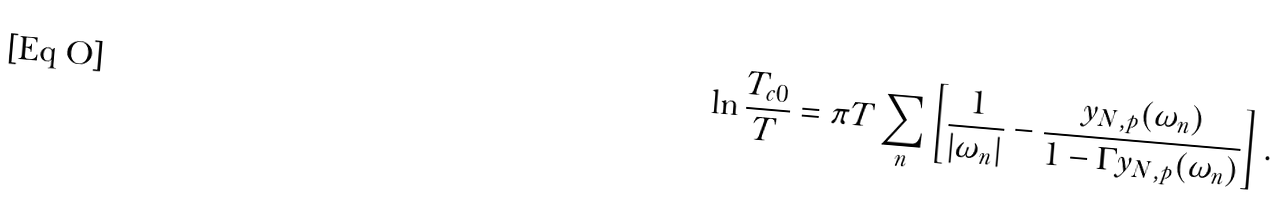<formula> <loc_0><loc_0><loc_500><loc_500>\ln \frac { T _ { c 0 } } { T } = \pi T \sum _ { n } \left [ \frac { 1 } { | \omega _ { n } | } - \frac { y _ { N , p } ( \omega _ { n } ) } { 1 - \Gamma y _ { N , p } ( \omega _ { n } ) } \right ] .</formula> 